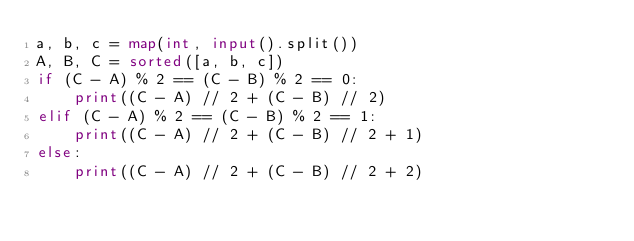<code> <loc_0><loc_0><loc_500><loc_500><_Python_>a, b, c = map(int, input().split())
A, B, C = sorted([a, b, c])
if (C - A) % 2 == (C - B) % 2 == 0:
    print((C - A) // 2 + (C - B) // 2)
elif (C - A) % 2 == (C - B) % 2 == 1:
    print((C - A) // 2 + (C - B) // 2 + 1)
else:
    print((C - A) // 2 + (C - B) // 2 + 2)</code> 